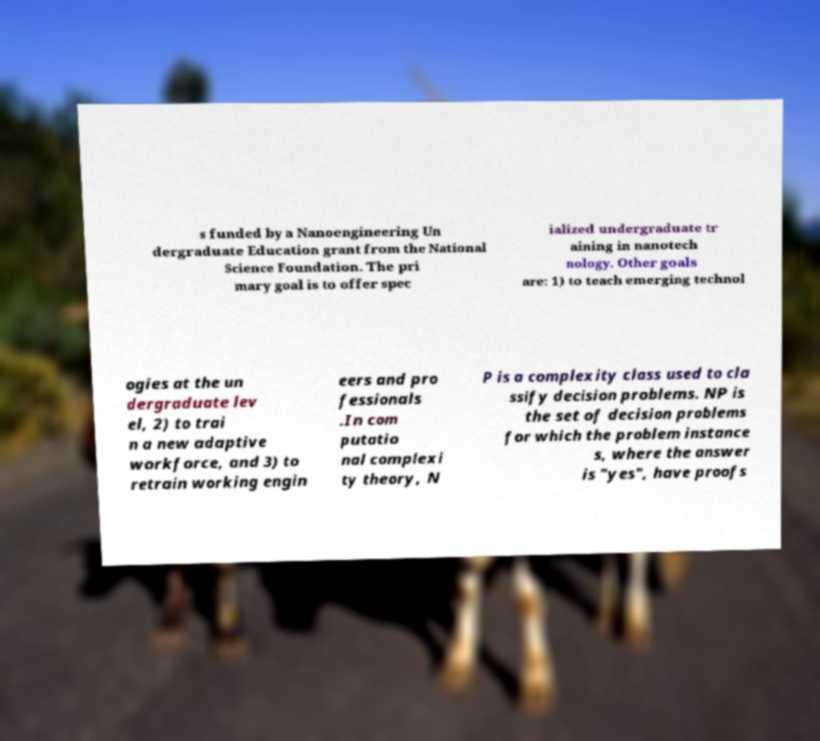Can you read and provide the text displayed in the image?This photo seems to have some interesting text. Can you extract and type it out for me? s funded by a Nanoengineering Un dergraduate Education grant from the National Science Foundation. The pri mary goal is to offer spec ialized undergraduate tr aining in nanotech nology. Other goals are: 1) to teach emerging technol ogies at the un dergraduate lev el, 2) to trai n a new adaptive workforce, and 3) to retrain working engin eers and pro fessionals .In com putatio nal complexi ty theory, N P is a complexity class used to cla ssify decision problems. NP is the set of decision problems for which the problem instance s, where the answer is "yes", have proofs 